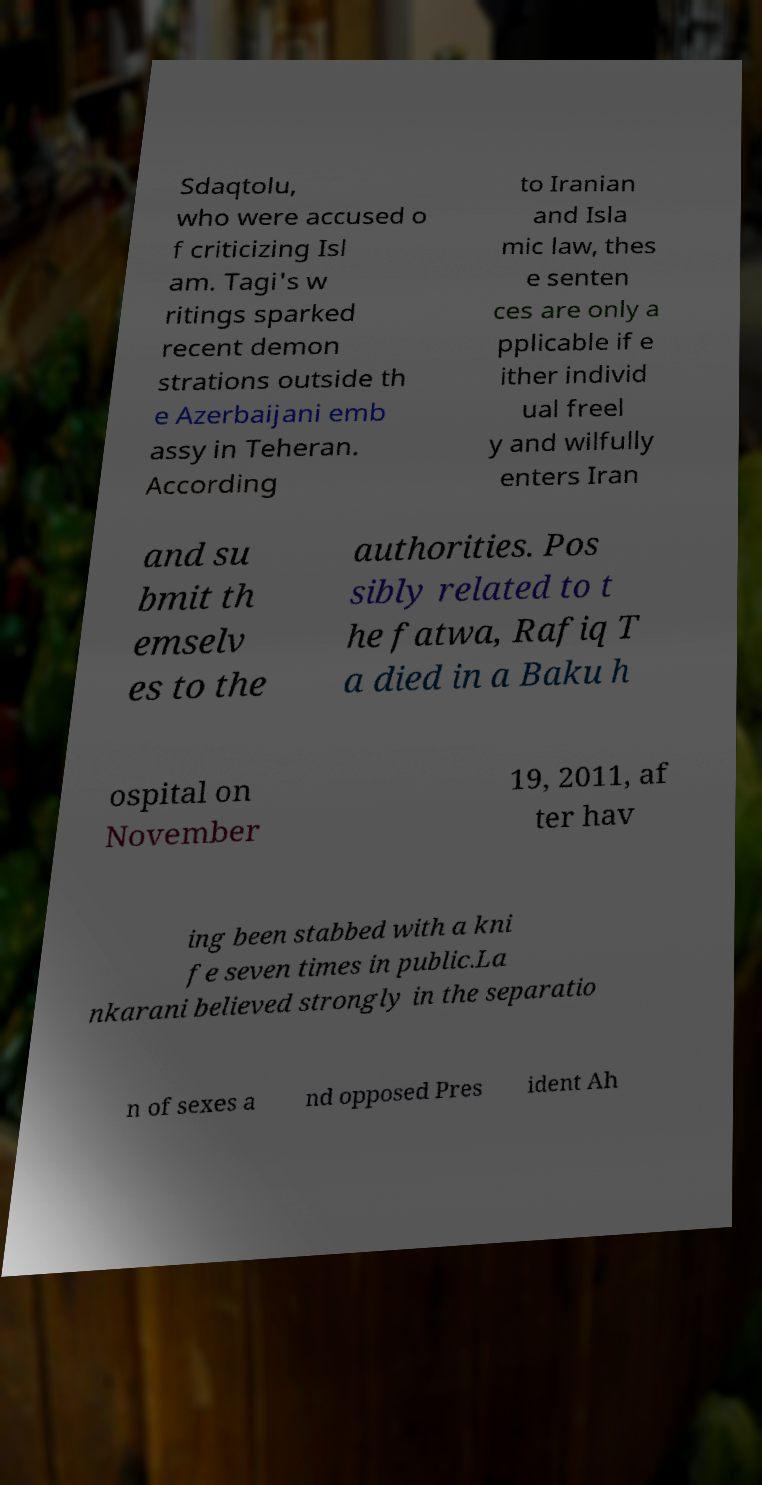For documentation purposes, I need the text within this image transcribed. Could you provide that? Sdaqtolu, who were accused o f criticizing Isl am. Tagi's w ritings sparked recent demon strations outside th e Azerbaijani emb assy in Teheran. According to Iranian and Isla mic law, thes e senten ces are only a pplicable if e ither individ ual freel y and wilfully enters Iran and su bmit th emselv es to the authorities. Pos sibly related to t he fatwa, Rafiq T a died in a Baku h ospital on November 19, 2011, af ter hav ing been stabbed with a kni fe seven times in public.La nkarani believed strongly in the separatio n of sexes a nd opposed Pres ident Ah 